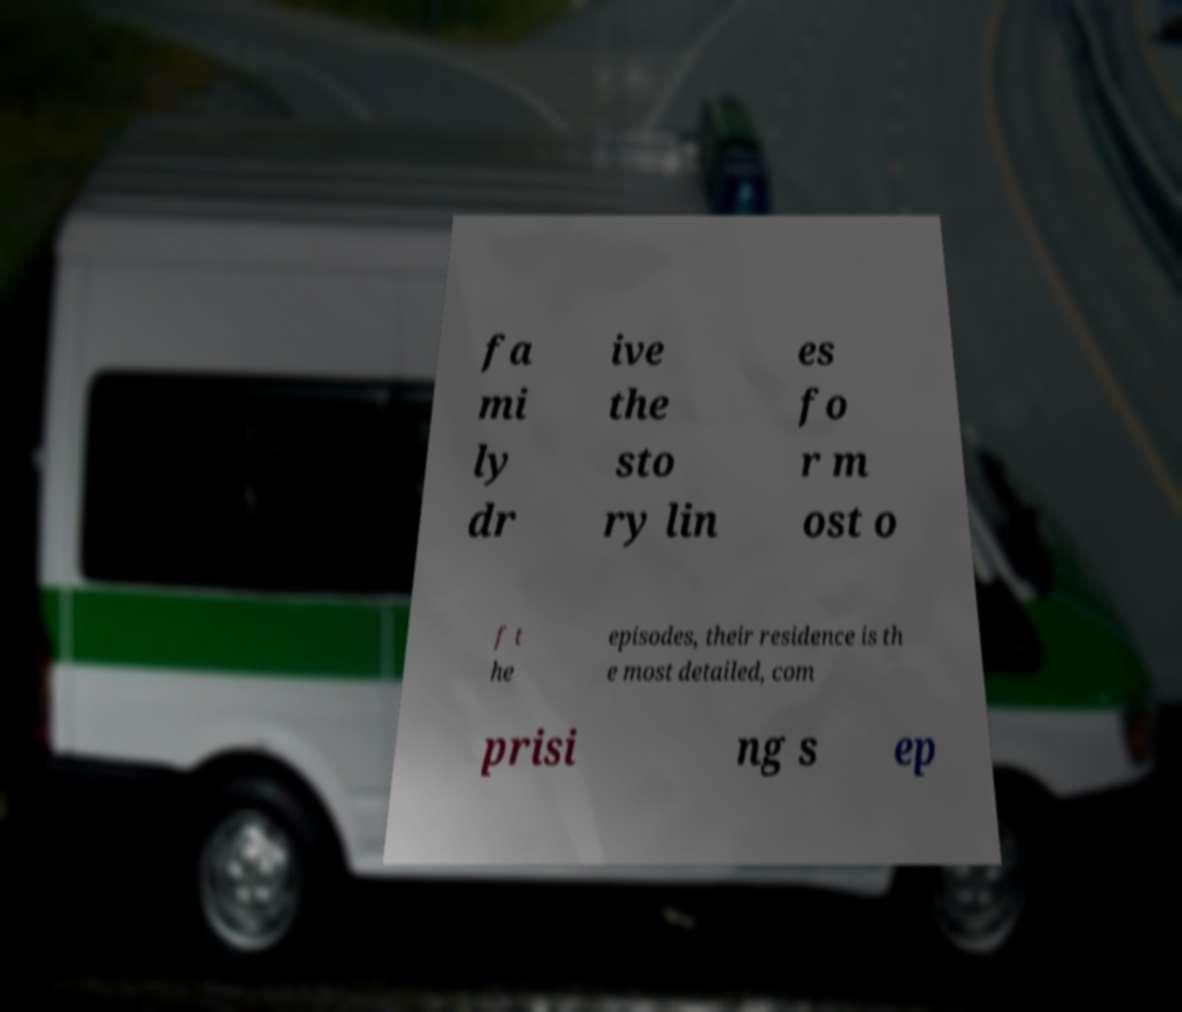There's text embedded in this image that I need extracted. Can you transcribe it verbatim? fa mi ly dr ive the sto ry lin es fo r m ost o f t he episodes, their residence is th e most detailed, com prisi ng s ep 